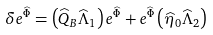Convert formula to latex. <formula><loc_0><loc_0><loc_500><loc_500>\delta e ^ { \widehat { \Phi } } = \left ( \widehat { Q } _ { B } \widehat { \Lambda } _ { 1 } \right ) e ^ { \widehat { \Phi } } + e ^ { \widehat { \Phi } } \left ( \widehat { \eta } _ { 0 } \widehat { \Lambda } _ { 2 } \right )</formula> 